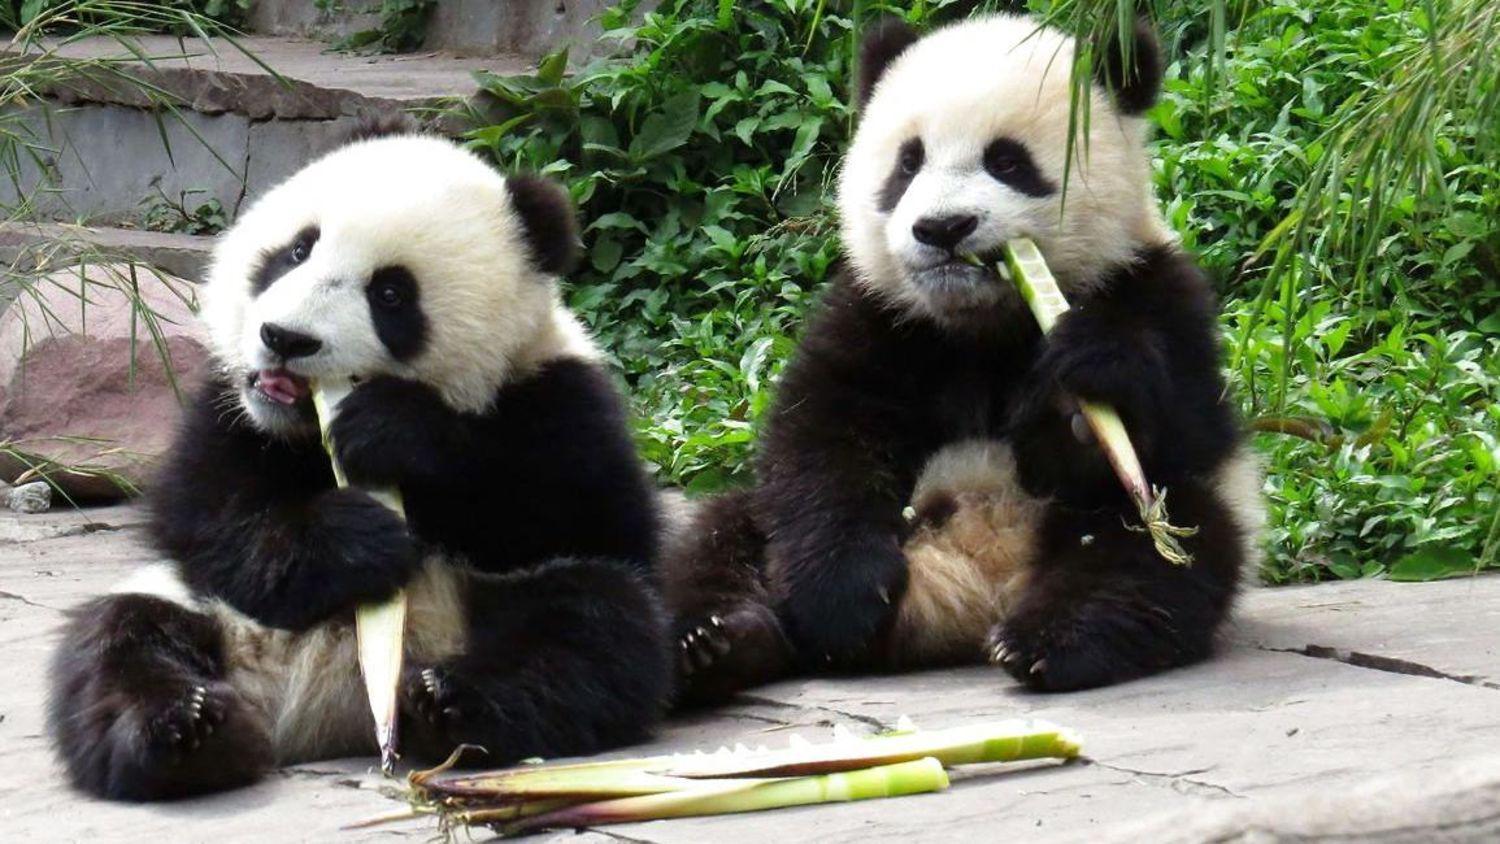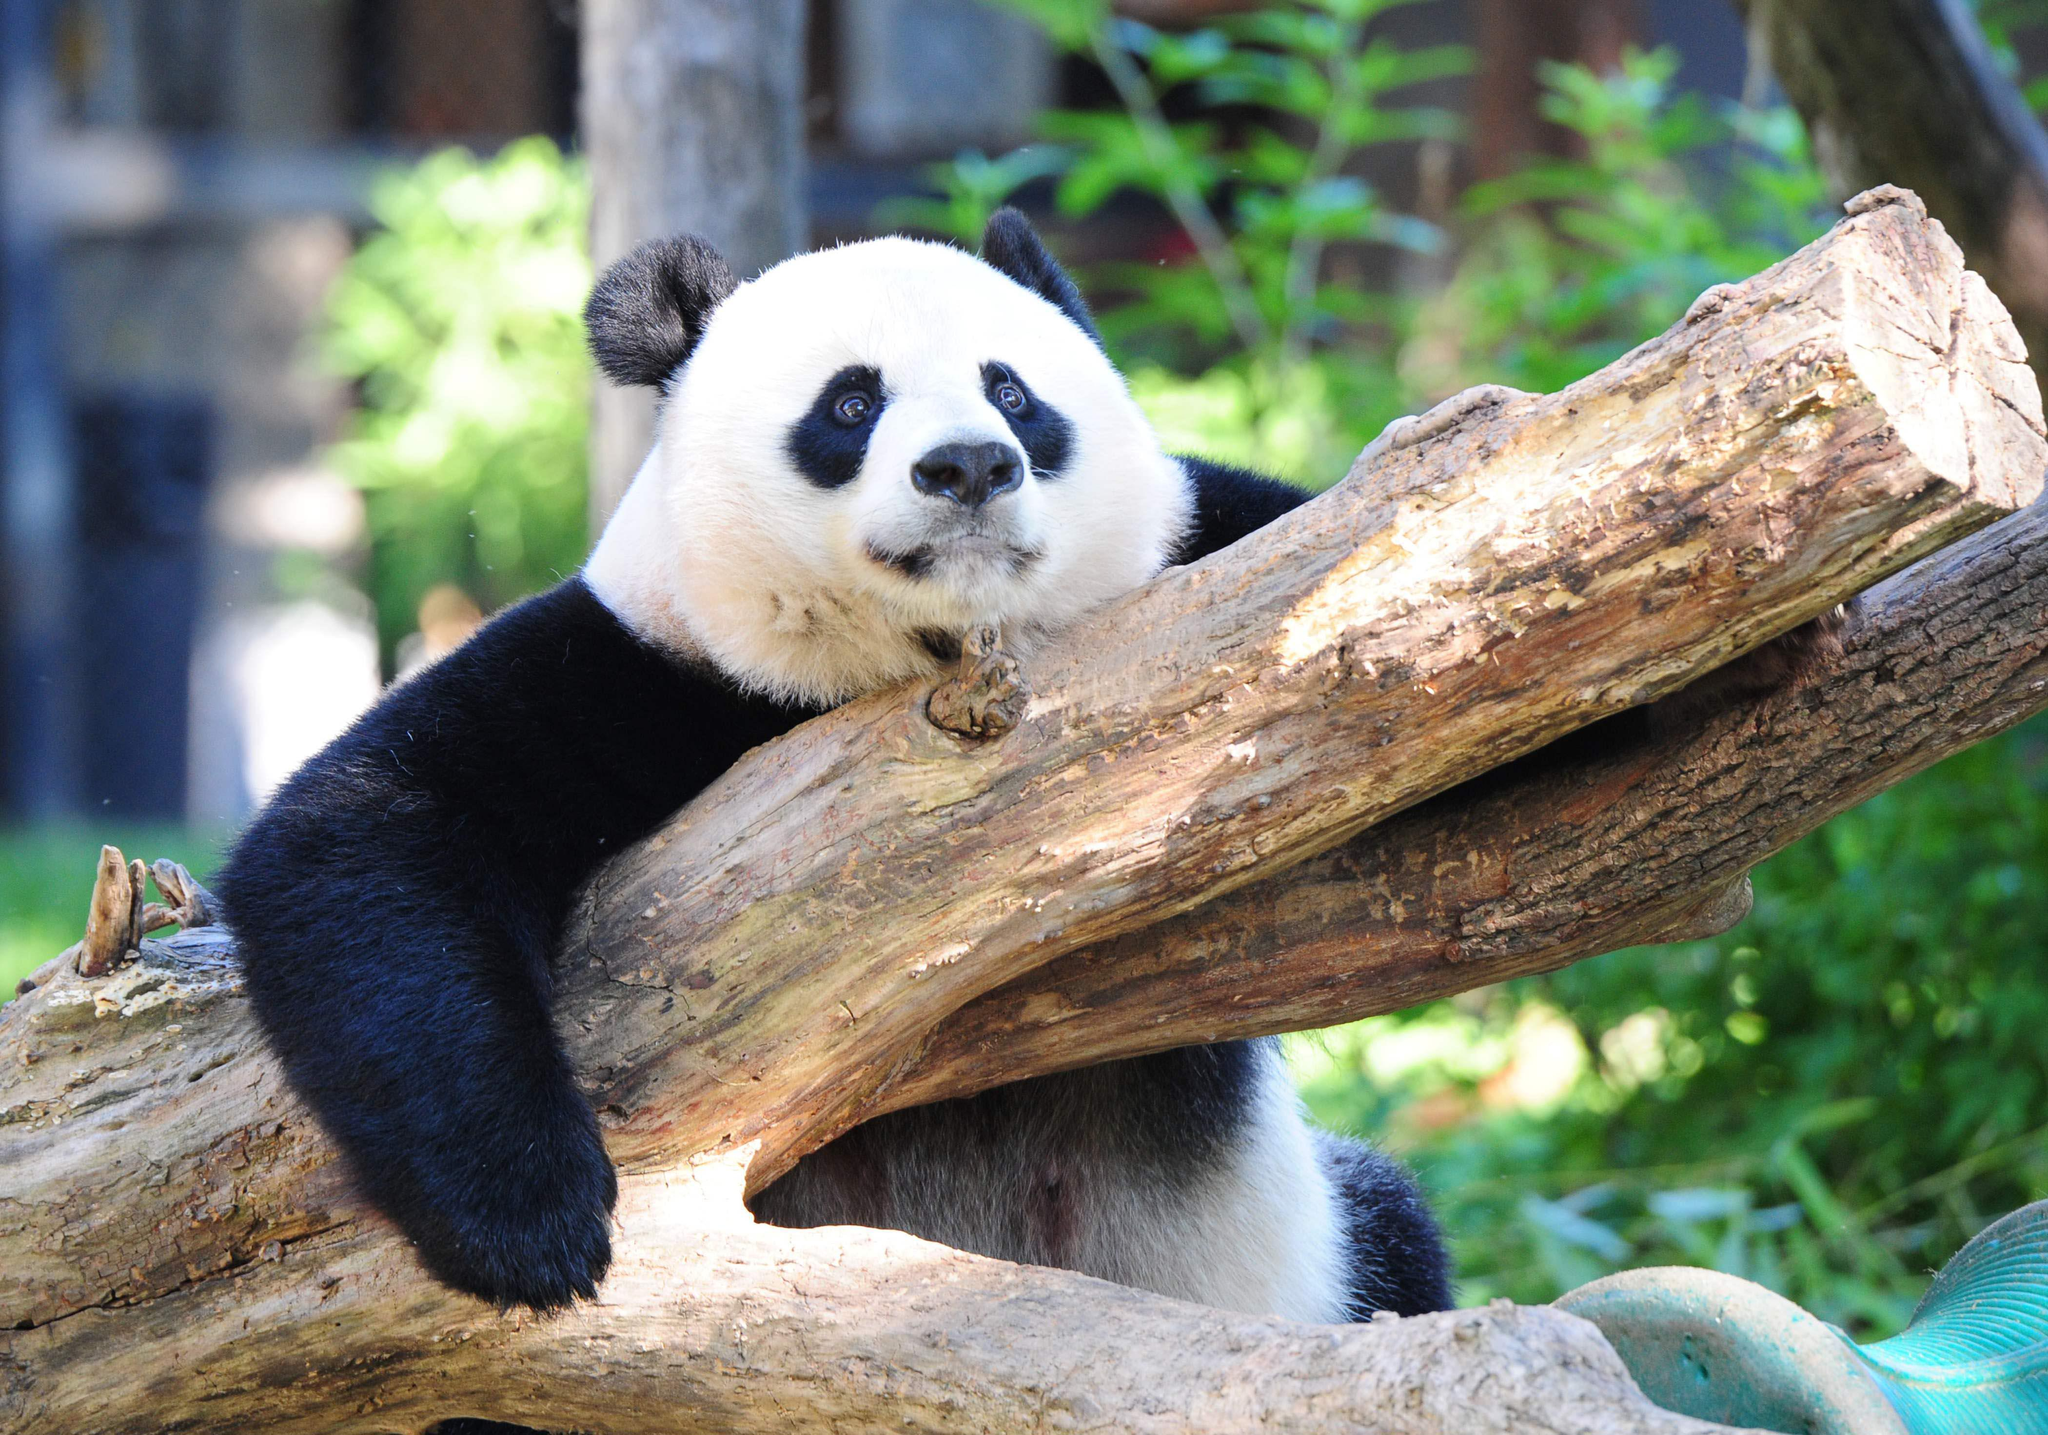The first image is the image on the left, the second image is the image on the right. For the images shown, is this caption "One image shows a pair of pandas side-by-side in similar poses, and the other features just one panda." true? Answer yes or no. Yes. The first image is the image on the left, the second image is the image on the right. Evaluate the accuracy of this statement regarding the images: "One giant panda is resting its chin on a log.". Is it true? Answer yes or no. Yes. 